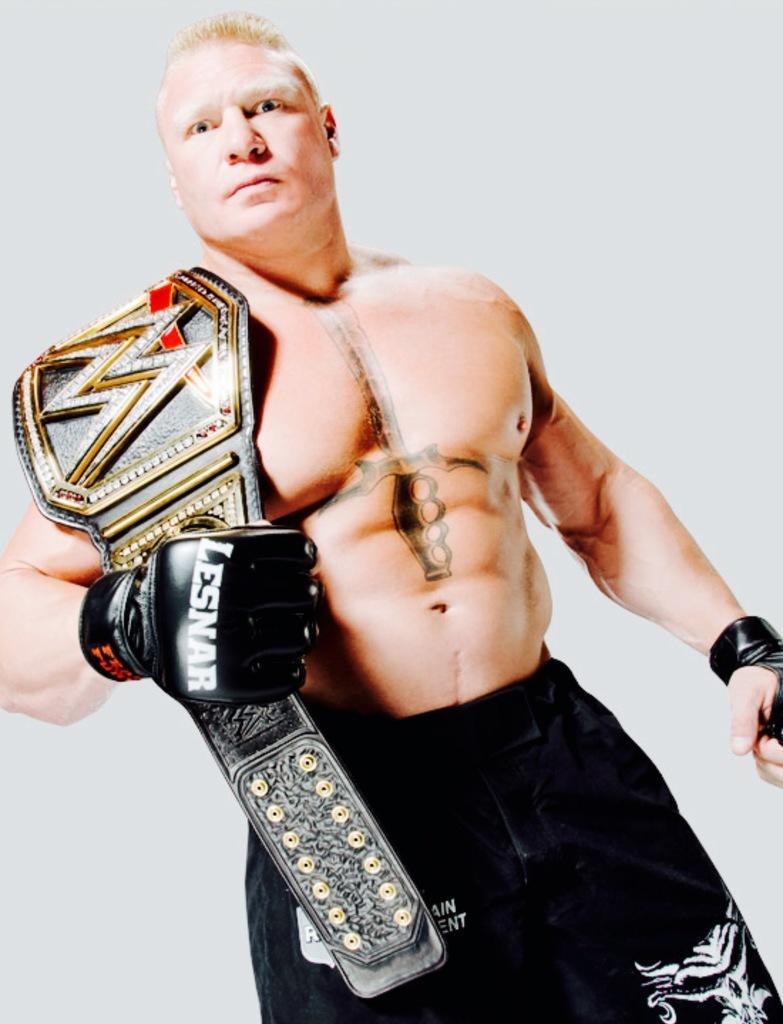Please provide a concise description of this image. In the middle of this image, there is a person in a black color shirt having a belt on his shoulder, wearing black color glove and standing. And the background is white in color. 